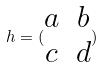Convert formula to latex. <formula><loc_0><loc_0><loc_500><loc_500>h = ( \begin{matrix} a & b \\ c & d \end{matrix} )</formula> 